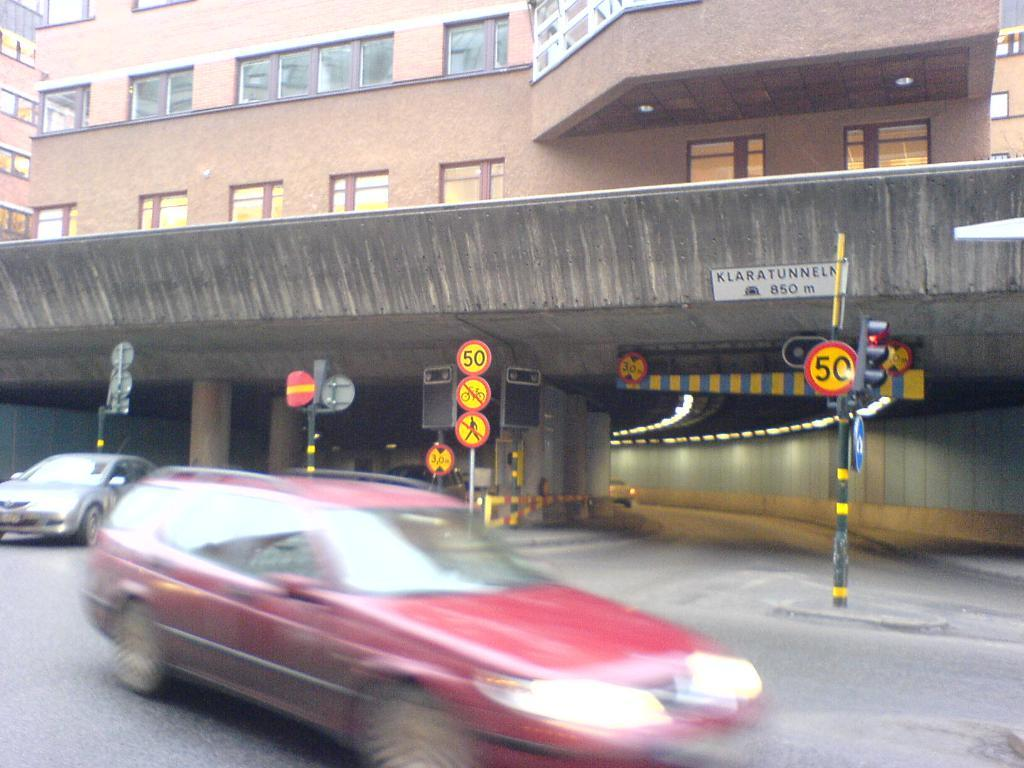<image>
Summarize the visual content of the image. A blurred red car on a street with a 50 sign in the background. 